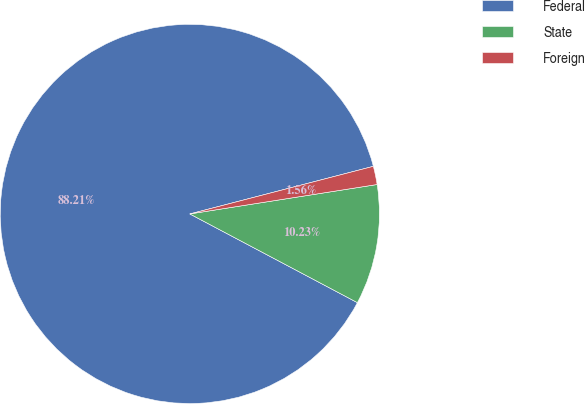Convert chart. <chart><loc_0><loc_0><loc_500><loc_500><pie_chart><fcel>Federal<fcel>State<fcel>Foreign<nl><fcel>88.21%<fcel>10.23%<fcel>1.56%<nl></chart> 